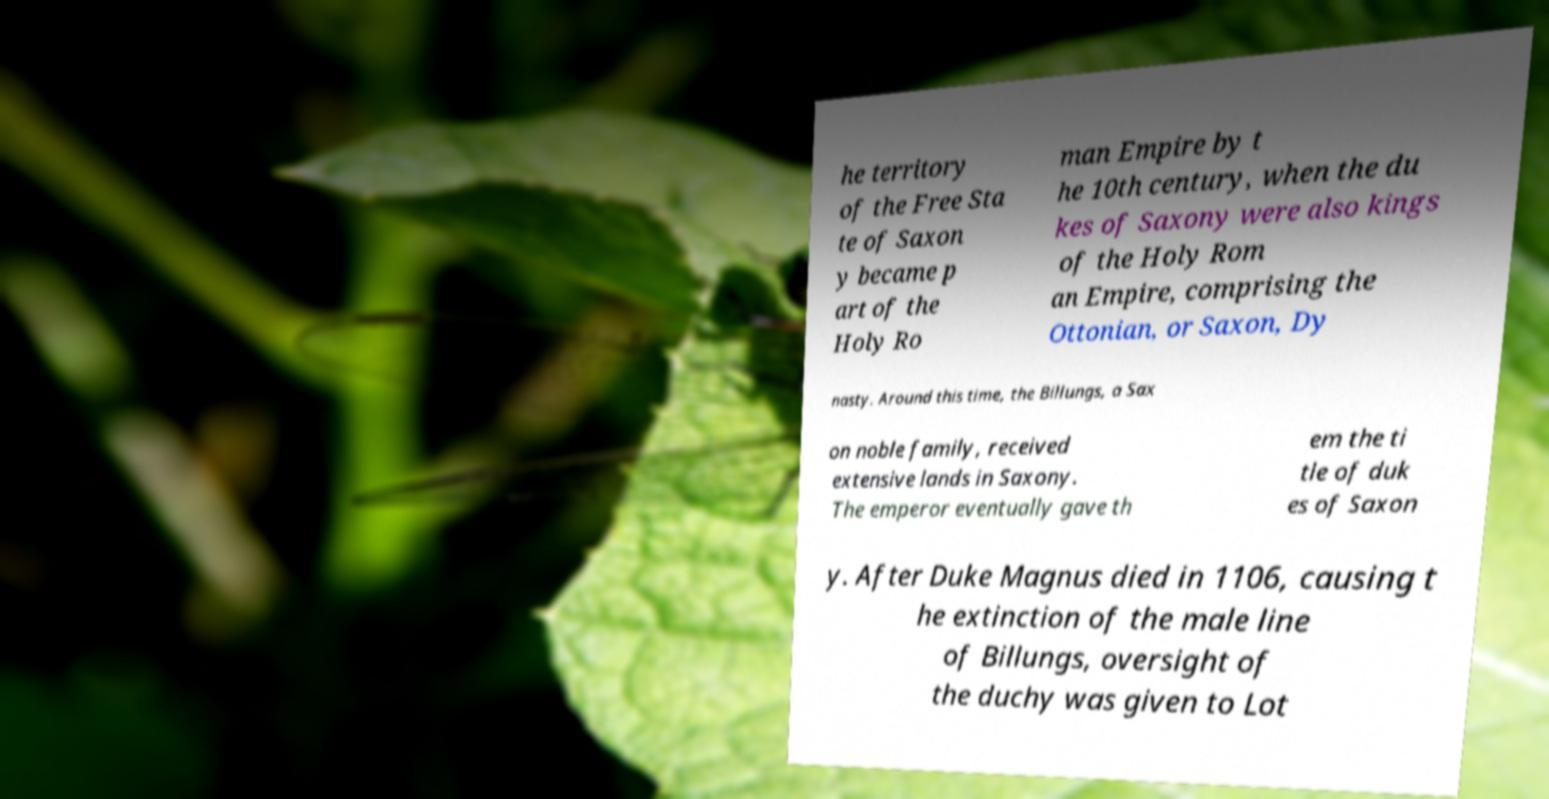Could you assist in decoding the text presented in this image and type it out clearly? he territory of the Free Sta te of Saxon y became p art of the Holy Ro man Empire by t he 10th century, when the du kes of Saxony were also kings of the Holy Rom an Empire, comprising the Ottonian, or Saxon, Dy nasty. Around this time, the Billungs, a Sax on noble family, received extensive lands in Saxony. The emperor eventually gave th em the ti tle of duk es of Saxon y. After Duke Magnus died in 1106, causing t he extinction of the male line of Billungs, oversight of the duchy was given to Lot 